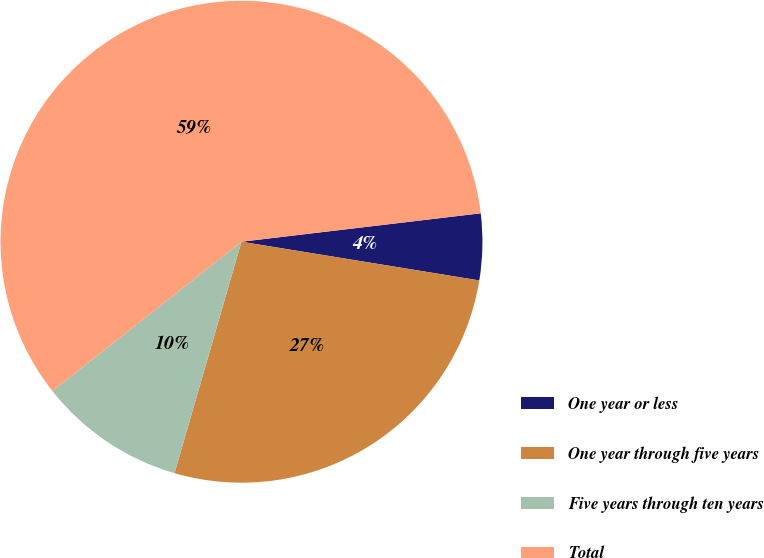<chart> <loc_0><loc_0><loc_500><loc_500><pie_chart><fcel>One year or less<fcel>One year through five years<fcel>Five years through ten years<fcel>Total<nl><fcel>4.45%<fcel>26.91%<fcel>9.88%<fcel>58.75%<nl></chart> 